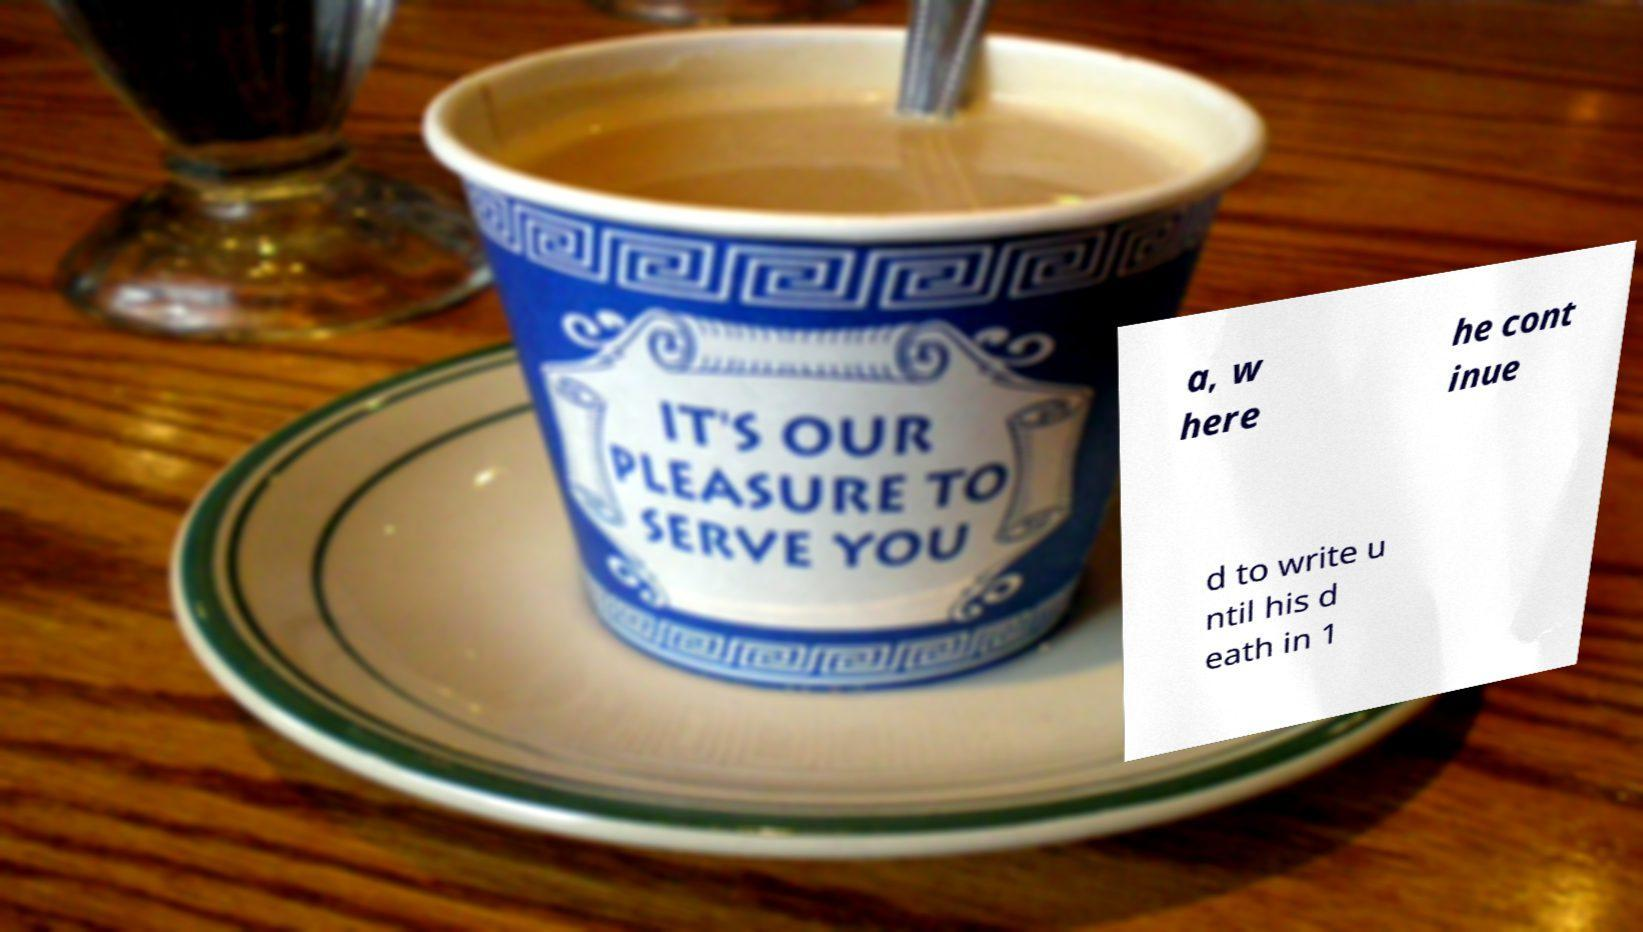Can you accurately transcribe the text from the provided image for me? a, w here he cont inue d to write u ntil his d eath in 1 